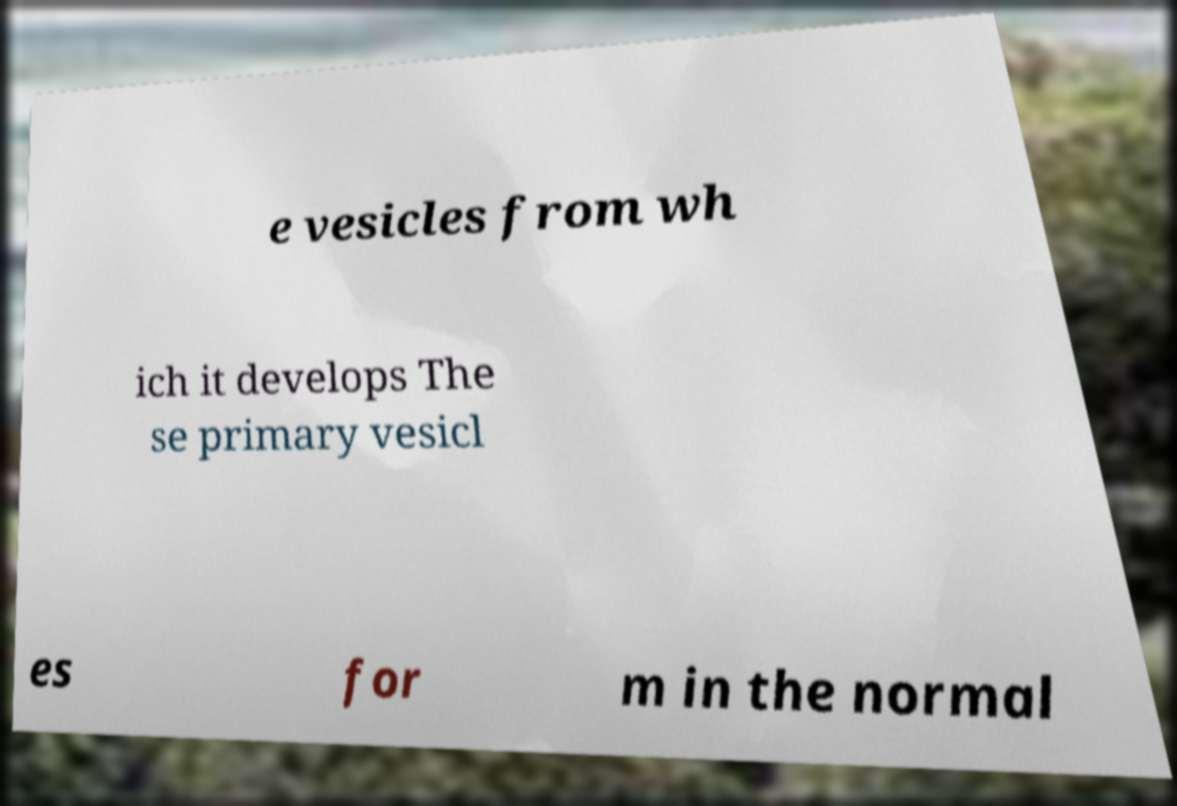Could you assist in decoding the text presented in this image and type it out clearly? e vesicles from wh ich it develops The se primary vesicl es for m in the normal 